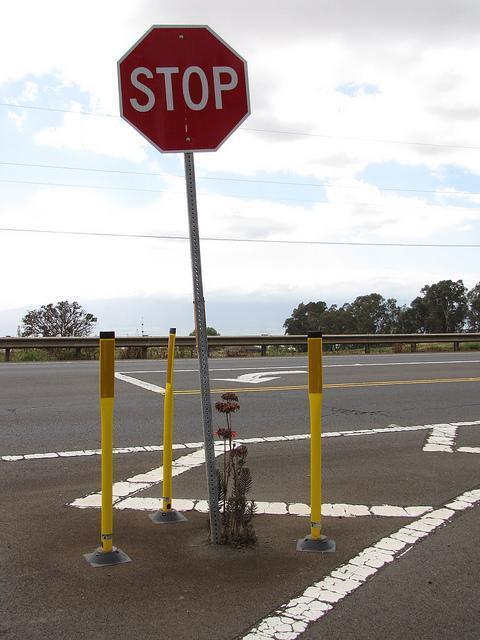How many sides on the sign?
Give a very brief answer. 8. How many stop signs can be seen?
Give a very brief answer. 1. How many people are only seen from the back on the image?
Give a very brief answer. 0. 